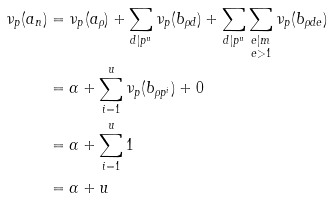Convert formula to latex. <formula><loc_0><loc_0><loc_500><loc_500>\nu _ { p } ( a _ { n } ) & = \nu _ { p } ( a _ { \rho } ) + \sum _ { d | p ^ { u } } \nu _ { p } ( b _ { \rho d } ) + \sum _ { d | p ^ { u } } \sum _ { \substack { e | m \\ e > 1 } } \nu _ { p } ( b _ { \rho d e } ) \\ & = \alpha + \sum _ { i = 1 } ^ { u } \nu _ { p } ( b _ { \rho p ^ { i } } ) + 0 \\ & = \alpha + \sum _ { i = 1 } ^ { u } 1 \\ & = \alpha + u</formula> 